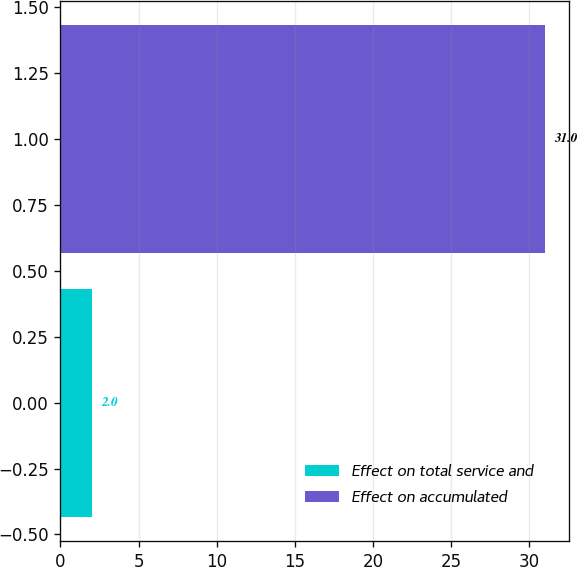<chart> <loc_0><loc_0><loc_500><loc_500><bar_chart><fcel>Effect on total service and<fcel>Effect on accumulated<nl><fcel>2<fcel>31<nl></chart> 